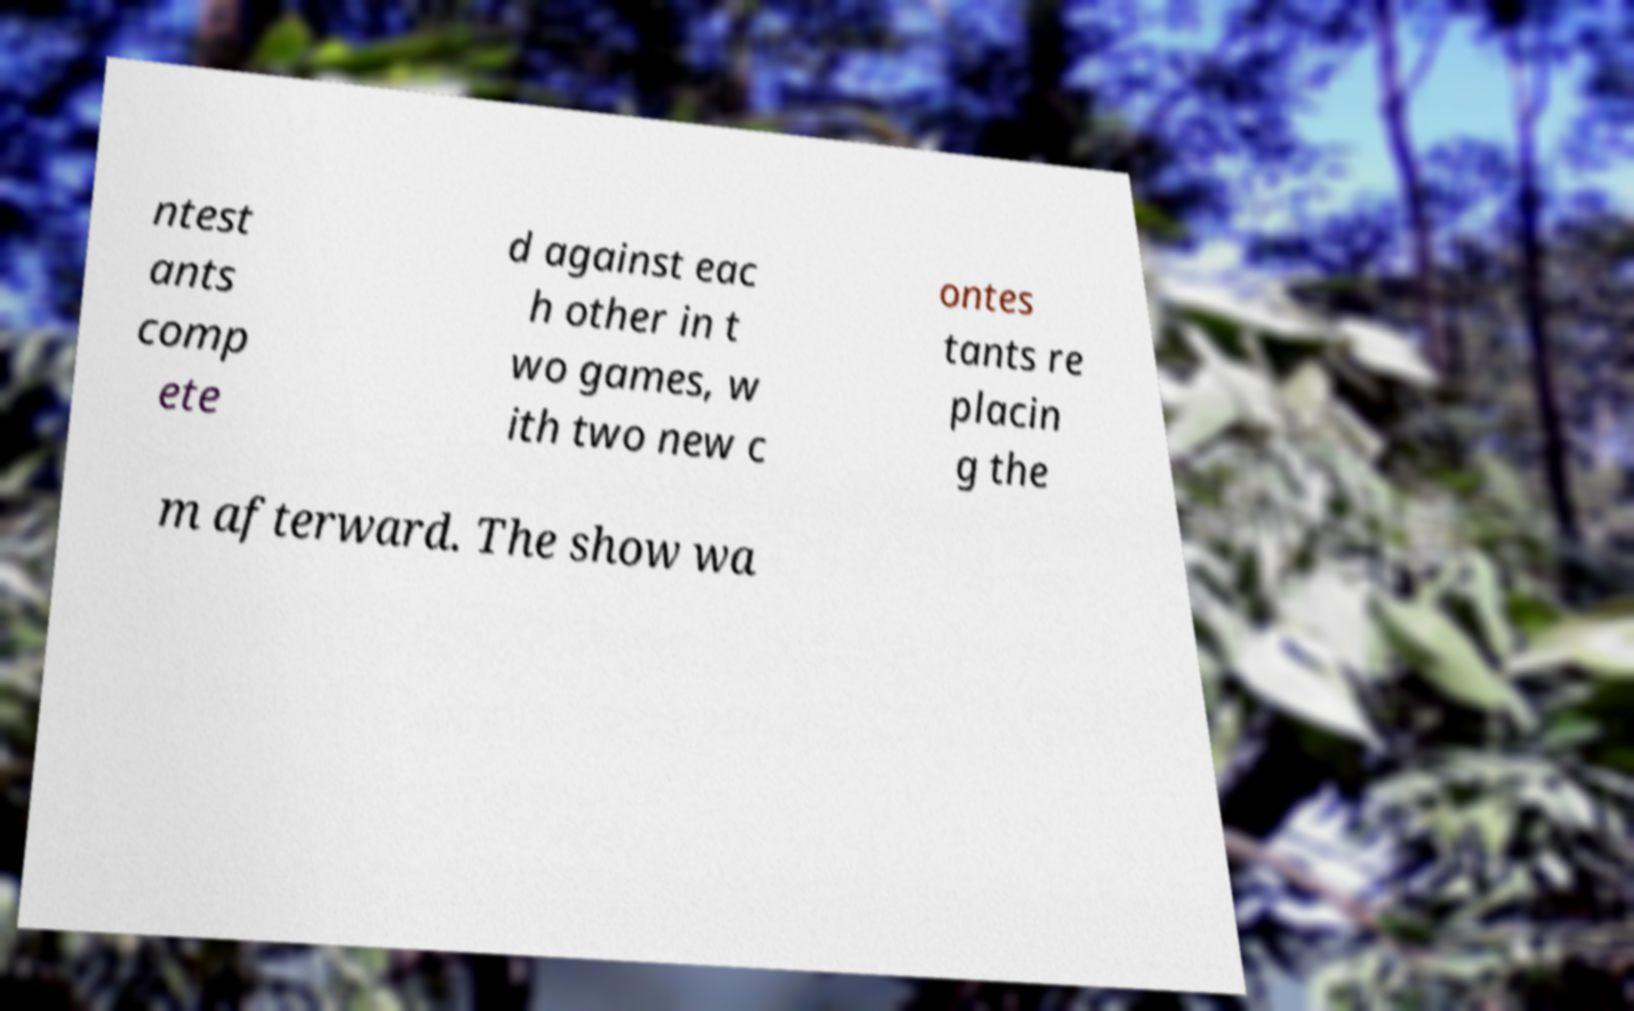For documentation purposes, I need the text within this image transcribed. Could you provide that? ntest ants comp ete d against eac h other in t wo games, w ith two new c ontes tants re placin g the m afterward. The show wa 